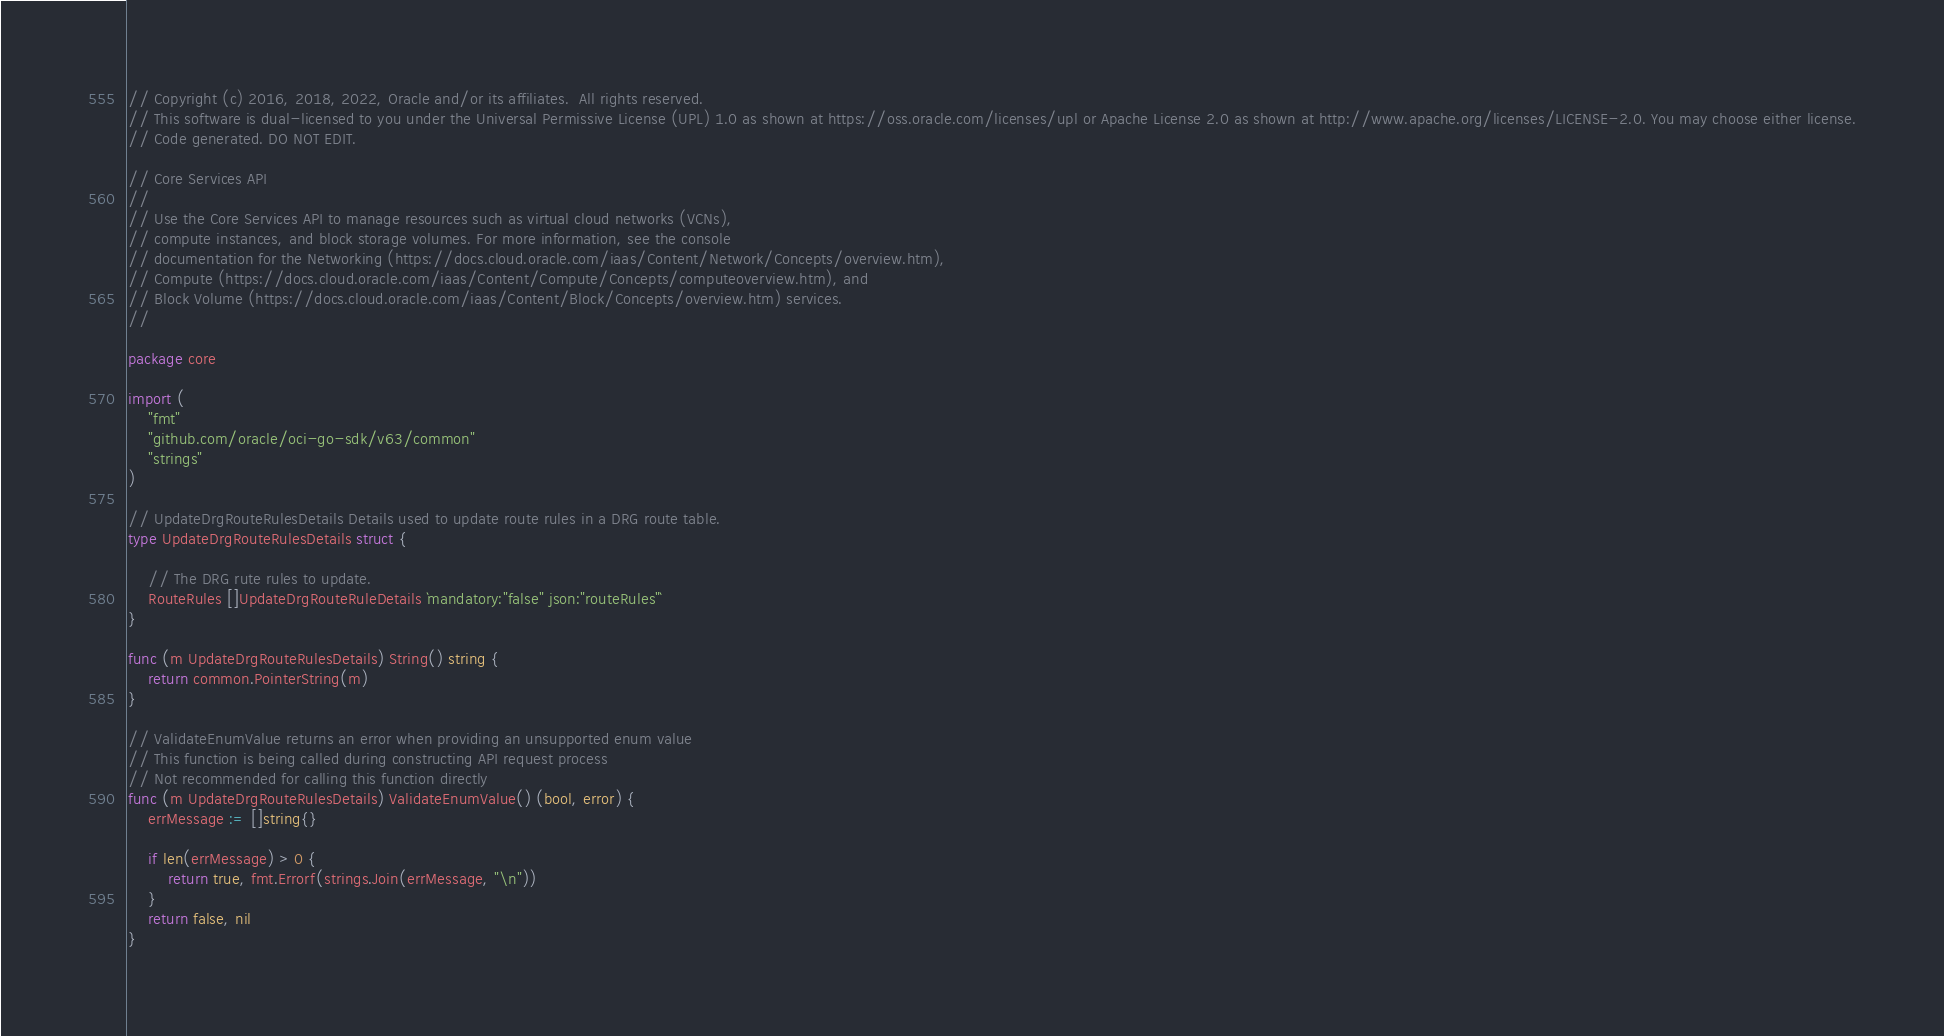Convert code to text. <code><loc_0><loc_0><loc_500><loc_500><_Go_>// Copyright (c) 2016, 2018, 2022, Oracle and/or its affiliates.  All rights reserved.
// This software is dual-licensed to you under the Universal Permissive License (UPL) 1.0 as shown at https://oss.oracle.com/licenses/upl or Apache License 2.0 as shown at http://www.apache.org/licenses/LICENSE-2.0. You may choose either license.
// Code generated. DO NOT EDIT.

// Core Services API
//
// Use the Core Services API to manage resources such as virtual cloud networks (VCNs),
// compute instances, and block storage volumes. For more information, see the console
// documentation for the Networking (https://docs.cloud.oracle.com/iaas/Content/Network/Concepts/overview.htm),
// Compute (https://docs.cloud.oracle.com/iaas/Content/Compute/Concepts/computeoverview.htm), and
// Block Volume (https://docs.cloud.oracle.com/iaas/Content/Block/Concepts/overview.htm) services.
//

package core

import (
	"fmt"
	"github.com/oracle/oci-go-sdk/v63/common"
	"strings"
)

// UpdateDrgRouteRulesDetails Details used to update route rules in a DRG route table.
type UpdateDrgRouteRulesDetails struct {

	// The DRG rute rules to update.
	RouteRules []UpdateDrgRouteRuleDetails `mandatory:"false" json:"routeRules"`
}

func (m UpdateDrgRouteRulesDetails) String() string {
	return common.PointerString(m)
}

// ValidateEnumValue returns an error when providing an unsupported enum value
// This function is being called during constructing API request process
// Not recommended for calling this function directly
func (m UpdateDrgRouteRulesDetails) ValidateEnumValue() (bool, error) {
	errMessage := []string{}

	if len(errMessage) > 0 {
		return true, fmt.Errorf(strings.Join(errMessage, "\n"))
	}
	return false, nil
}
</code> 